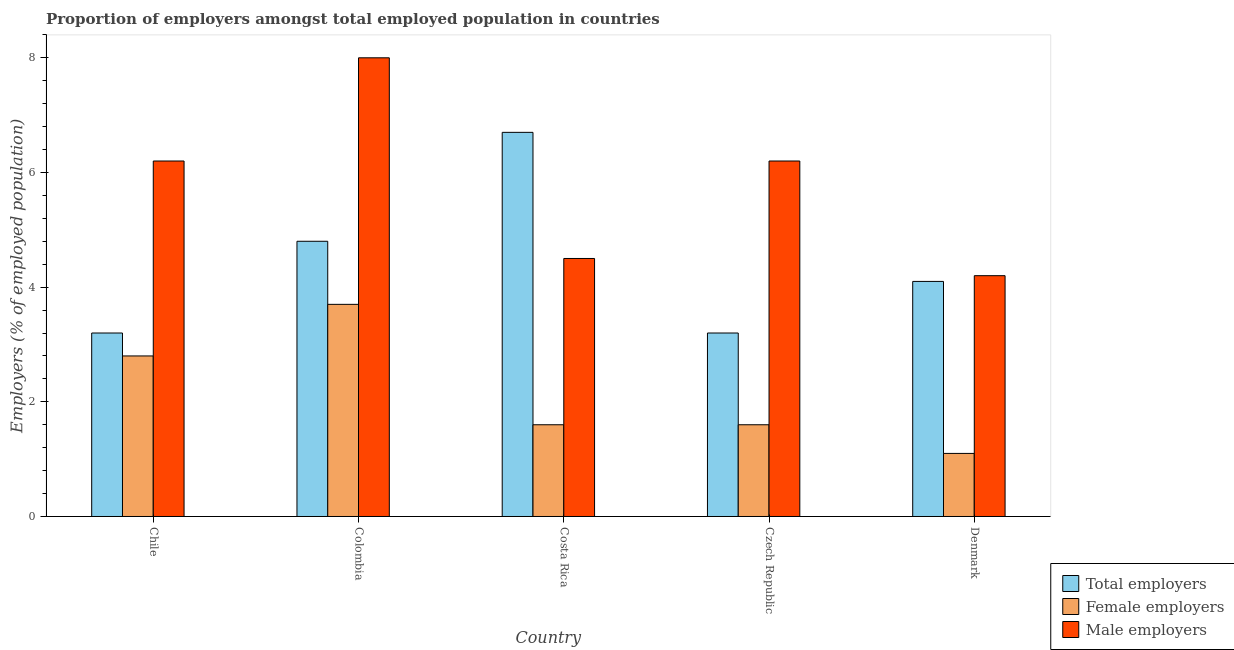How many groups of bars are there?
Your response must be concise. 5. Are the number of bars per tick equal to the number of legend labels?
Give a very brief answer. Yes. How many bars are there on the 4th tick from the left?
Give a very brief answer. 3. How many bars are there on the 4th tick from the right?
Provide a succinct answer. 3. What is the label of the 2nd group of bars from the left?
Make the answer very short. Colombia. In how many cases, is the number of bars for a given country not equal to the number of legend labels?
Provide a succinct answer. 0. What is the percentage of total employers in Denmark?
Offer a terse response. 4.1. Across all countries, what is the maximum percentage of female employers?
Offer a terse response. 3.7. Across all countries, what is the minimum percentage of female employers?
Your answer should be compact. 1.1. In which country was the percentage of female employers maximum?
Offer a very short reply. Colombia. What is the total percentage of female employers in the graph?
Offer a terse response. 10.8. What is the difference between the percentage of male employers in Chile and that in Czech Republic?
Offer a very short reply. 0. What is the difference between the percentage of male employers in Colombia and the percentage of female employers in Czech Republic?
Offer a very short reply. 6.4. What is the average percentage of male employers per country?
Offer a very short reply. 5.82. What is the difference between the percentage of male employers and percentage of total employers in Costa Rica?
Keep it short and to the point. -2.2. In how many countries, is the percentage of female employers greater than 6.4 %?
Your answer should be very brief. 0. What is the ratio of the percentage of male employers in Chile to that in Costa Rica?
Ensure brevity in your answer.  1.38. Is the difference between the percentage of total employers in Colombia and Costa Rica greater than the difference between the percentage of female employers in Colombia and Costa Rica?
Offer a terse response. No. What is the difference between the highest and the second highest percentage of total employers?
Keep it short and to the point. 1.9. What is the difference between the highest and the lowest percentage of total employers?
Provide a short and direct response. 3.5. In how many countries, is the percentage of female employers greater than the average percentage of female employers taken over all countries?
Offer a very short reply. 2. What does the 3rd bar from the left in Costa Rica represents?
Your answer should be compact. Male employers. What does the 3rd bar from the right in Costa Rica represents?
Your answer should be compact. Total employers. How many bars are there?
Provide a succinct answer. 15. Are all the bars in the graph horizontal?
Your answer should be compact. No. How many countries are there in the graph?
Offer a very short reply. 5. What is the difference between two consecutive major ticks on the Y-axis?
Offer a very short reply. 2. Are the values on the major ticks of Y-axis written in scientific E-notation?
Keep it short and to the point. No. Does the graph contain grids?
Provide a short and direct response. No. What is the title of the graph?
Keep it short and to the point. Proportion of employers amongst total employed population in countries. What is the label or title of the X-axis?
Provide a succinct answer. Country. What is the label or title of the Y-axis?
Make the answer very short. Employers (% of employed population). What is the Employers (% of employed population) of Total employers in Chile?
Provide a succinct answer. 3.2. What is the Employers (% of employed population) of Female employers in Chile?
Give a very brief answer. 2.8. What is the Employers (% of employed population) of Male employers in Chile?
Provide a short and direct response. 6.2. What is the Employers (% of employed population) of Total employers in Colombia?
Give a very brief answer. 4.8. What is the Employers (% of employed population) of Female employers in Colombia?
Provide a succinct answer. 3.7. What is the Employers (% of employed population) in Male employers in Colombia?
Your response must be concise. 8. What is the Employers (% of employed population) in Total employers in Costa Rica?
Your answer should be compact. 6.7. What is the Employers (% of employed population) in Female employers in Costa Rica?
Offer a terse response. 1.6. What is the Employers (% of employed population) in Male employers in Costa Rica?
Offer a very short reply. 4.5. What is the Employers (% of employed population) of Total employers in Czech Republic?
Offer a terse response. 3.2. What is the Employers (% of employed population) in Female employers in Czech Republic?
Your response must be concise. 1.6. What is the Employers (% of employed population) in Male employers in Czech Republic?
Provide a short and direct response. 6.2. What is the Employers (% of employed population) in Total employers in Denmark?
Give a very brief answer. 4.1. What is the Employers (% of employed population) of Female employers in Denmark?
Make the answer very short. 1.1. What is the Employers (% of employed population) in Male employers in Denmark?
Your answer should be compact. 4.2. Across all countries, what is the maximum Employers (% of employed population) in Total employers?
Give a very brief answer. 6.7. Across all countries, what is the maximum Employers (% of employed population) of Female employers?
Offer a very short reply. 3.7. Across all countries, what is the maximum Employers (% of employed population) in Male employers?
Your answer should be compact. 8. Across all countries, what is the minimum Employers (% of employed population) of Total employers?
Your answer should be compact. 3.2. Across all countries, what is the minimum Employers (% of employed population) in Female employers?
Give a very brief answer. 1.1. Across all countries, what is the minimum Employers (% of employed population) of Male employers?
Offer a very short reply. 4.2. What is the total Employers (% of employed population) of Male employers in the graph?
Provide a succinct answer. 29.1. What is the difference between the Employers (% of employed population) of Total employers in Chile and that in Costa Rica?
Offer a terse response. -3.5. What is the difference between the Employers (% of employed population) of Female employers in Chile and that in Costa Rica?
Provide a short and direct response. 1.2. What is the difference between the Employers (% of employed population) of Female employers in Chile and that in Denmark?
Your response must be concise. 1.7. What is the difference between the Employers (% of employed population) in Total employers in Colombia and that in Costa Rica?
Give a very brief answer. -1.9. What is the difference between the Employers (% of employed population) in Male employers in Colombia and that in Czech Republic?
Your answer should be compact. 1.8. What is the difference between the Employers (% of employed population) in Total employers in Colombia and that in Denmark?
Your response must be concise. 0.7. What is the difference between the Employers (% of employed population) in Male employers in Colombia and that in Denmark?
Provide a succinct answer. 3.8. What is the difference between the Employers (% of employed population) in Total employers in Costa Rica and that in Czech Republic?
Offer a very short reply. 3.5. What is the difference between the Employers (% of employed population) of Female employers in Costa Rica and that in Czech Republic?
Provide a short and direct response. 0. What is the difference between the Employers (% of employed population) of Total employers in Costa Rica and that in Denmark?
Provide a short and direct response. 2.6. What is the difference between the Employers (% of employed population) of Male employers in Costa Rica and that in Denmark?
Your response must be concise. 0.3. What is the difference between the Employers (% of employed population) of Total employers in Czech Republic and that in Denmark?
Your response must be concise. -0.9. What is the difference between the Employers (% of employed population) in Female employers in Czech Republic and that in Denmark?
Give a very brief answer. 0.5. What is the difference between the Employers (% of employed population) in Male employers in Czech Republic and that in Denmark?
Offer a terse response. 2. What is the difference between the Employers (% of employed population) of Female employers in Chile and the Employers (% of employed population) of Male employers in Colombia?
Your answer should be compact. -5.2. What is the difference between the Employers (% of employed population) in Total employers in Chile and the Employers (% of employed population) in Male employers in Costa Rica?
Provide a succinct answer. -1.3. What is the difference between the Employers (% of employed population) in Total employers in Chile and the Employers (% of employed population) in Female employers in Denmark?
Your response must be concise. 2.1. What is the difference between the Employers (% of employed population) of Female employers in Colombia and the Employers (% of employed population) of Male employers in Costa Rica?
Offer a very short reply. -0.8. What is the difference between the Employers (% of employed population) in Total employers in Colombia and the Employers (% of employed population) in Male employers in Denmark?
Your answer should be very brief. 0.6. What is the difference between the Employers (% of employed population) of Female employers in Colombia and the Employers (% of employed population) of Male employers in Denmark?
Keep it short and to the point. -0.5. What is the difference between the Employers (% of employed population) of Total employers in Costa Rica and the Employers (% of employed population) of Female employers in Czech Republic?
Your answer should be very brief. 5.1. What is the difference between the Employers (% of employed population) in Total employers in Costa Rica and the Employers (% of employed population) in Male employers in Czech Republic?
Offer a very short reply. 0.5. What is the difference between the Employers (% of employed population) of Female employers in Costa Rica and the Employers (% of employed population) of Male employers in Czech Republic?
Provide a short and direct response. -4.6. What is the difference between the Employers (% of employed population) in Total employers in Costa Rica and the Employers (% of employed population) in Female employers in Denmark?
Your answer should be very brief. 5.6. What is the difference between the Employers (% of employed population) of Female employers in Costa Rica and the Employers (% of employed population) of Male employers in Denmark?
Your answer should be compact. -2.6. What is the difference between the Employers (% of employed population) of Total employers in Czech Republic and the Employers (% of employed population) of Female employers in Denmark?
Your answer should be very brief. 2.1. What is the difference between the Employers (% of employed population) of Total employers in Czech Republic and the Employers (% of employed population) of Male employers in Denmark?
Give a very brief answer. -1. What is the average Employers (% of employed population) in Female employers per country?
Your answer should be very brief. 2.16. What is the average Employers (% of employed population) of Male employers per country?
Make the answer very short. 5.82. What is the difference between the Employers (% of employed population) in Total employers and Employers (% of employed population) in Female employers in Chile?
Your response must be concise. 0.4. What is the difference between the Employers (% of employed population) of Total employers and Employers (% of employed population) of Female employers in Colombia?
Your answer should be very brief. 1.1. What is the difference between the Employers (% of employed population) in Total employers and Employers (% of employed population) in Male employers in Colombia?
Provide a succinct answer. -3.2. What is the difference between the Employers (% of employed population) of Female employers and Employers (% of employed population) of Male employers in Colombia?
Offer a very short reply. -4.3. What is the difference between the Employers (% of employed population) in Total employers and Employers (% of employed population) in Female employers in Costa Rica?
Keep it short and to the point. 5.1. What is the difference between the Employers (% of employed population) in Total employers and Employers (% of employed population) in Male employers in Costa Rica?
Your answer should be very brief. 2.2. What is the difference between the Employers (% of employed population) in Female employers and Employers (% of employed population) in Male employers in Costa Rica?
Your answer should be very brief. -2.9. What is the difference between the Employers (% of employed population) in Total employers and Employers (% of employed population) in Female employers in Czech Republic?
Your answer should be very brief. 1.6. What is the difference between the Employers (% of employed population) in Total employers and Employers (% of employed population) in Male employers in Czech Republic?
Your response must be concise. -3. What is the difference between the Employers (% of employed population) in Female employers and Employers (% of employed population) in Male employers in Czech Republic?
Give a very brief answer. -4.6. What is the difference between the Employers (% of employed population) in Female employers and Employers (% of employed population) in Male employers in Denmark?
Your response must be concise. -3.1. What is the ratio of the Employers (% of employed population) in Total employers in Chile to that in Colombia?
Keep it short and to the point. 0.67. What is the ratio of the Employers (% of employed population) in Female employers in Chile to that in Colombia?
Your response must be concise. 0.76. What is the ratio of the Employers (% of employed population) in Male employers in Chile to that in Colombia?
Your response must be concise. 0.78. What is the ratio of the Employers (% of employed population) of Total employers in Chile to that in Costa Rica?
Offer a very short reply. 0.48. What is the ratio of the Employers (% of employed population) of Female employers in Chile to that in Costa Rica?
Your response must be concise. 1.75. What is the ratio of the Employers (% of employed population) in Male employers in Chile to that in Costa Rica?
Your answer should be compact. 1.38. What is the ratio of the Employers (% of employed population) of Female employers in Chile to that in Czech Republic?
Your answer should be very brief. 1.75. What is the ratio of the Employers (% of employed population) in Male employers in Chile to that in Czech Republic?
Make the answer very short. 1. What is the ratio of the Employers (% of employed population) of Total employers in Chile to that in Denmark?
Your answer should be compact. 0.78. What is the ratio of the Employers (% of employed population) of Female employers in Chile to that in Denmark?
Your answer should be compact. 2.55. What is the ratio of the Employers (% of employed population) in Male employers in Chile to that in Denmark?
Keep it short and to the point. 1.48. What is the ratio of the Employers (% of employed population) in Total employers in Colombia to that in Costa Rica?
Offer a terse response. 0.72. What is the ratio of the Employers (% of employed population) of Female employers in Colombia to that in Costa Rica?
Provide a short and direct response. 2.31. What is the ratio of the Employers (% of employed population) in Male employers in Colombia to that in Costa Rica?
Provide a short and direct response. 1.78. What is the ratio of the Employers (% of employed population) in Female employers in Colombia to that in Czech Republic?
Ensure brevity in your answer.  2.31. What is the ratio of the Employers (% of employed population) in Male employers in Colombia to that in Czech Republic?
Give a very brief answer. 1.29. What is the ratio of the Employers (% of employed population) of Total employers in Colombia to that in Denmark?
Your response must be concise. 1.17. What is the ratio of the Employers (% of employed population) of Female employers in Colombia to that in Denmark?
Ensure brevity in your answer.  3.36. What is the ratio of the Employers (% of employed population) in Male employers in Colombia to that in Denmark?
Offer a very short reply. 1.9. What is the ratio of the Employers (% of employed population) in Total employers in Costa Rica to that in Czech Republic?
Your answer should be compact. 2.09. What is the ratio of the Employers (% of employed population) of Female employers in Costa Rica to that in Czech Republic?
Keep it short and to the point. 1. What is the ratio of the Employers (% of employed population) of Male employers in Costa Rica to that in Czech Republic?
Give a very brief answer. 0.73. What is the ratio of the Employers (% of employed population) in Total employers in Costa Rica to that in Denmark?
Offer a very short reply. 1.63. What is the ratio of the Employers (% of employed population) in Female employers in Costa Rica to that in Denmark?
Give a very brief answer. 1.45. What is the ratio of the Employers (% of employed population) in Male employers in Costa Rica to that in Denmark?
Your answer should be very brief. 1.07. What is the ratio of the Employers (% of employed population) in Total employers in Czech Republic to that in Denmark?
Keep it short and to the point. 0.78. What is the ratio of the Employers (% of employed population) in Female employers in Czech Republic to that in Denmark?
Offer a terse response. 1.45. What is the ratio of the Employers (% of employed population) in Male employers in Czech Republic to that in Denmark?
Provide a succinct answer. 1.48. What is the difference between the highest and the second highest Employers (% of employed population) of Total employers?
Make the answer very short. 1.9. What is the difference between the highest and the second highest Employers (% of employed population) of Female employers?
Your answer should be very brief. 0.9. What is the difference between the highest and the second highest Employers (% of employed population) of Male employers?
Your answer should be very brief. 1.8. What is the difference between the highest and the lowest Employers (% of employed population) in Female employers?
Offer a terse response. 2.6. What is the difference between the highest and the lowest Employers (% of employed population) of Male employers?
Your answer should be very brief. 3.8. 